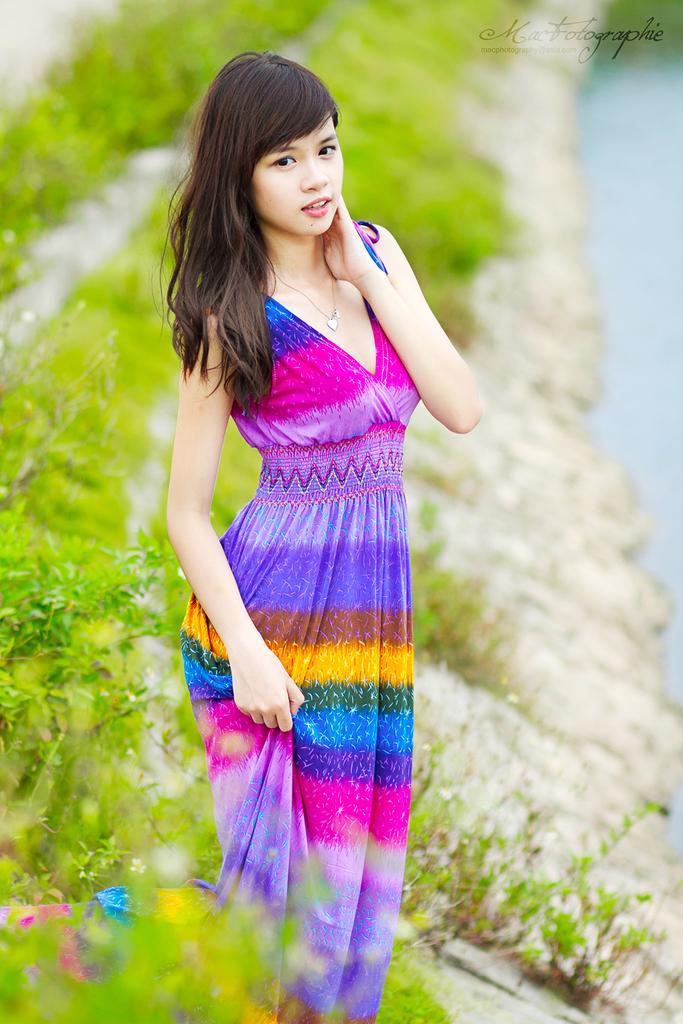Could you give a brief overview of what you see in this image? In the center of the image we can see a lady standing. In the background there are plants. 